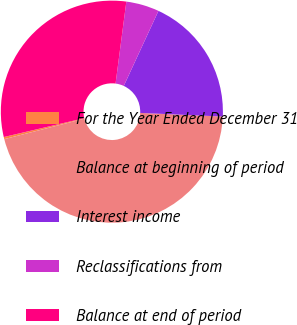Convert chart. <chart><loc_0><loc_0><loc_500><loc_500><pie_chart><fcel>For the Year Ended December 31<fcel>Balance at beginning of period<fcel>Interest income<fcel>Reclassifications from<fcel>Balance at end of period<nl><fcel>0.31%<fcel>45.32%<fcel>18.81%<fcel>4.81%<fcel>30.75%<nl></chart> 